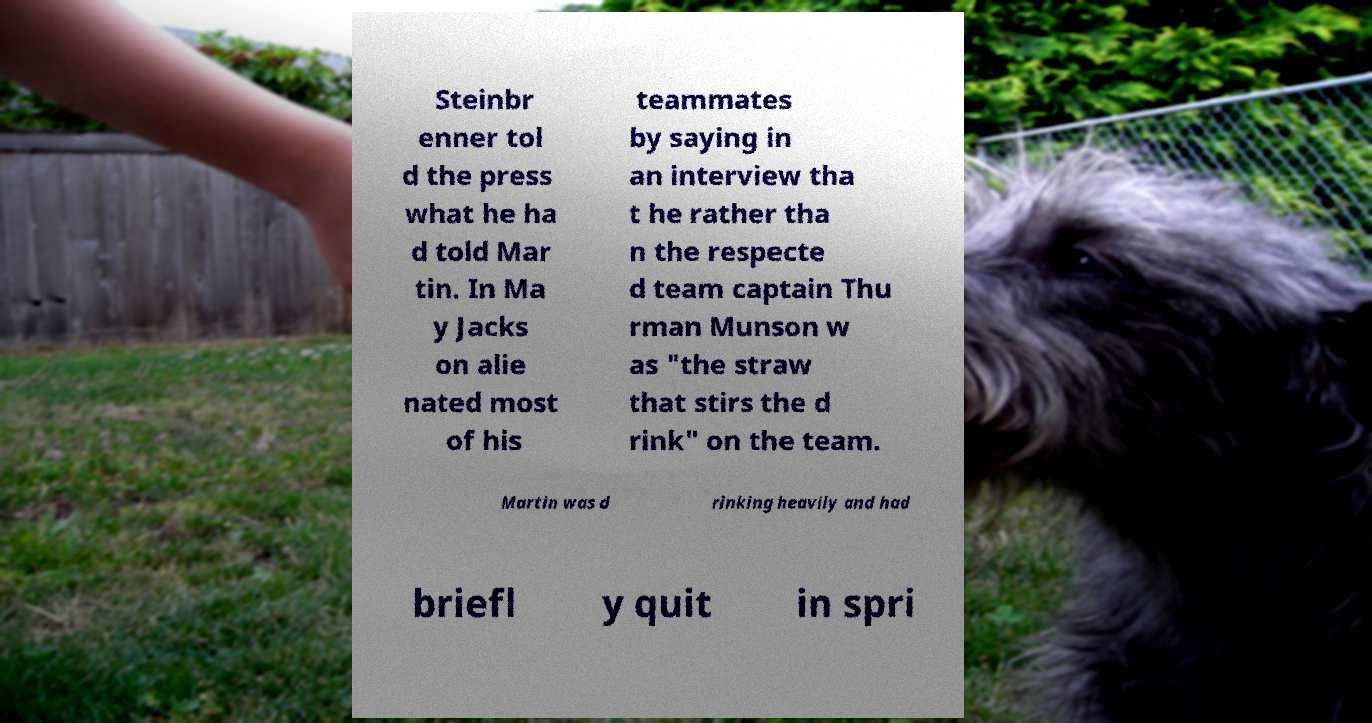For documentation purposes, I need the text within this image transcribed. Could you provide that? Steinbr enner tol d the press what he ha d told Mar tin. In Ma y Jacks on alie nated most of his teammates by saying in an interview tha t he rather tha n the respecte d team captain Thu rman Munson w as "the straw that stirs the d rink" on the team. Martin was d rinking heavily and had briefl y quit in spri 